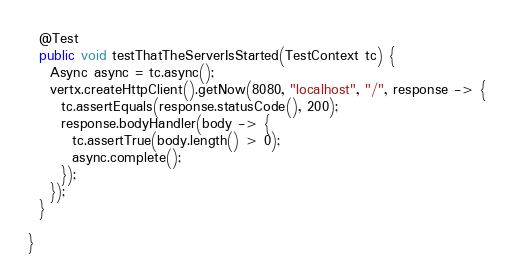<code> <loc_0><loc_0><loc_500><loc_500><_Java_>  @Test
  public void testThatTheServerIsStarted(TestContext tc) {
    Async async = tc.async();
    vertx.createHttpClient().getNow(8080, "localhost", "/", response -> {
      tc.assertEquals(response.statusCode(), 200);
      response.bodyHandler(body -> {
        tc.assertTrue(body.length() > 0);
        async.complete();
      });
    });
  }

}</code> 